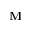<formula> <loc_0><loc_0><loc_500><loc_500>{ M }</formula> 